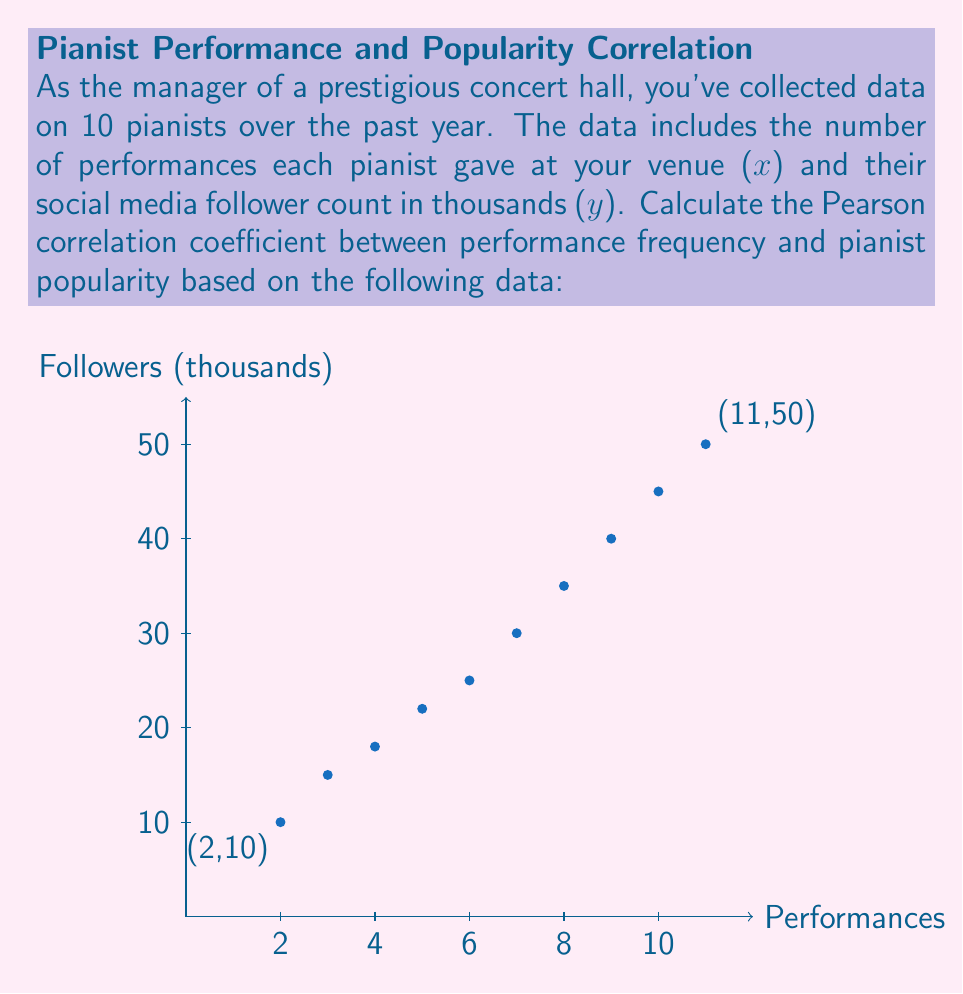What is the answer to this math problem? To calculate the Pearson correlation coefficient (r), we'll use the formula:

$$ r = \frac{n\sum xy - \sum x \sum y}{\sqrt{[n\sum x^2 - (\sum x)^2][n\sum y^2 - (\sum y)^2]}} $$

Where n is the number of data points.

Step 1: Calculate the sums and squared sums:
$\sum x = 65$, $\sum y = 290$, $\sum x^2 = 507$, $\sum y^2 = 10,450$

Step 2: Calculate $\sum xy$:
$\sum xy = 2(10) + 3(15) + 4(18) + 5(22) + 6(25) + 7(30) + 8(35) + 9(40) + 10(45) + 11(50) = 2,305$

Step 3: Apply the formula:

$$ r = \frac{10(2,305) - 65(290)}{\sqrt{[10(507) - 65^2][10(10,450) - 290^2]}} $$

$$ r = \frac{23,050 - 18,850}{\sqrt{(5,070 - 4,225)(104,500 - 84,100)}} $$

$$ r = \frac{4,200}{\sqrt{845 \cdot 20,400}} $$

$$ r = \frac{4,200}{\sqrt{17,238,000}} $$

$$ r = \frac{4,200}{4,152.59} $$

$$ r \approx 0.9971 $$

This value indicates a very strong positive correlation between the number of performances and the pianist's popularity (as measured by social media followers).
Answer: $r \approx 0.9971$ 